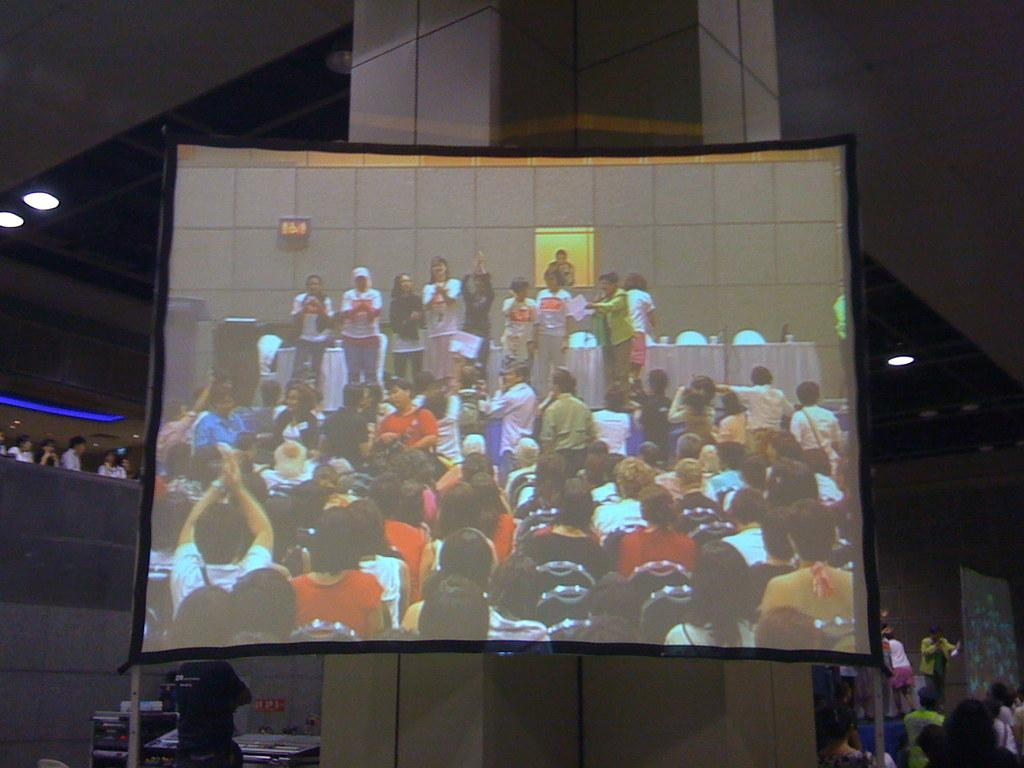What is the main object in the image? There is a screen in the image. What can be seen on the screen? There are persons visible on the screen. What are some of the positions of the persons on the screen? Some of the persons on the screen are sitting, and some are standing. What can be seen in the background of the image? There are lights visible in the background of the image. What type of mist can be seen covering the top of the screen in the image? There is no mist present in the image; it only shows a screen with persons on it and lights in the background. 